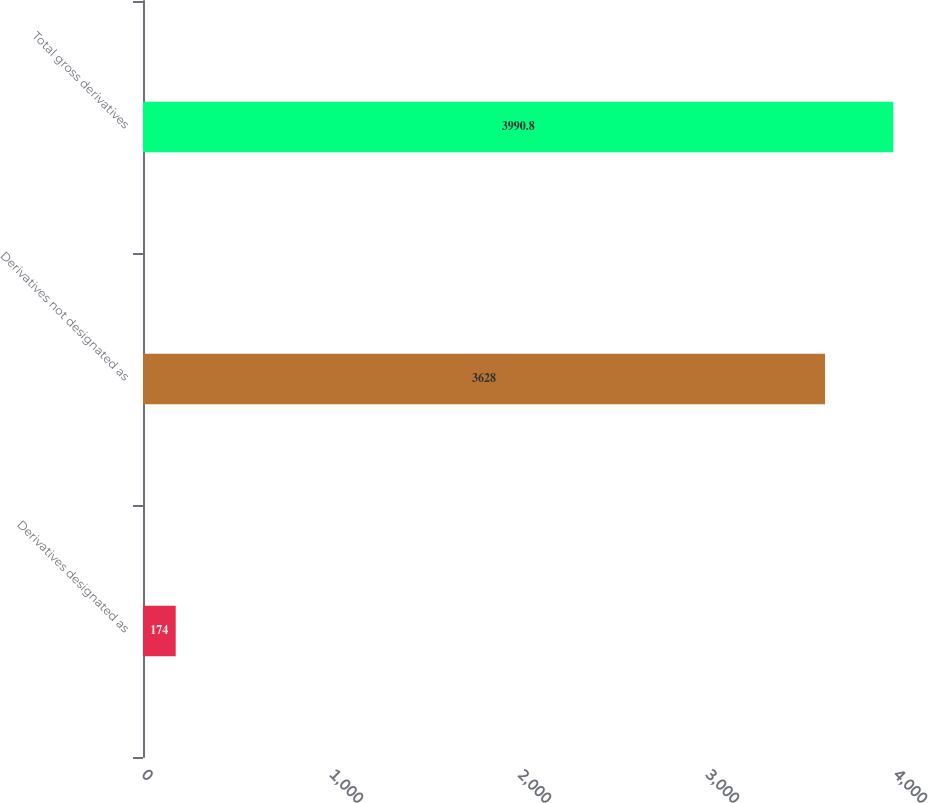Convert chart to OTSL. <chart><loc_0><loc_0><loc_500><loc_500><bar_chart><fcel>Derivatives designated as<fcel>Derivatives not designated as<fcel>Total gross derivatives<nl><fcel>174<fcel>3628<fcel>3990.8<nl></chart> 